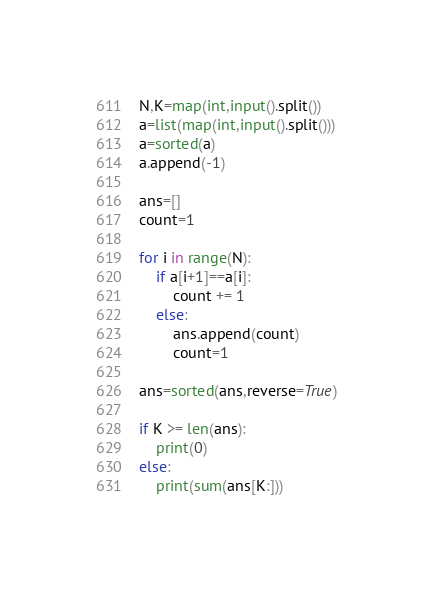<code> <loc_0><loc_0><loc_500><loc_500><_Python_>N,K=map(int,input().split())
a=list(map(int,input().split()))
a=sorted(a)
a.append(-1)

ans=[]
count=1

for i in range(N):
    if a[i+1]==a[i]:
        count += 1
    else:
        ans.append(count)
        count=1

ans=sorted(ans,reverse=True)

if K >= len(ans):
    print(0)
else:
    print(sum(ans[K:]))</code> 